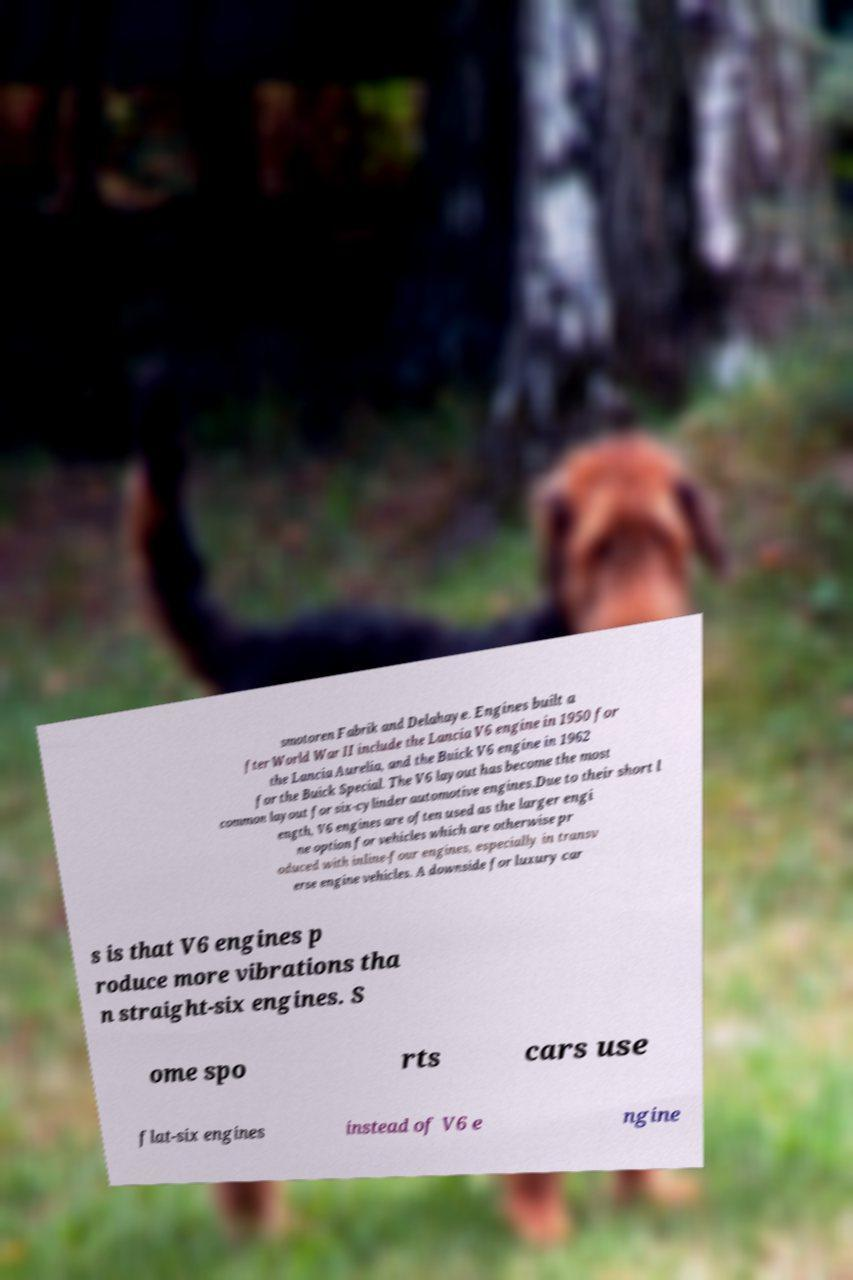What messages or text are displayed in this image? I need them in a readable, typed format. smotoren Fabrik and Delahaye. Engines built a fter World War II include the Lancia V6 engine in 1950 for the Lancia Aurelia, and the Buick V6 engine in 1962 for the Buick Special. The V6 layout has become the most common layout for six-cylinder automotive engines.Due to their short l ength, V6 engines are often used as the larger engi ne option for vehicles which are otherwise pr oduced with inline-four engines, especially in transv erse engine vehicles. A downside for luxury car s is that V6 engines p roduce more vibrations tha n straight-six engines. S ome spo rts cars use flat-six engines instead of V6 e ngine 